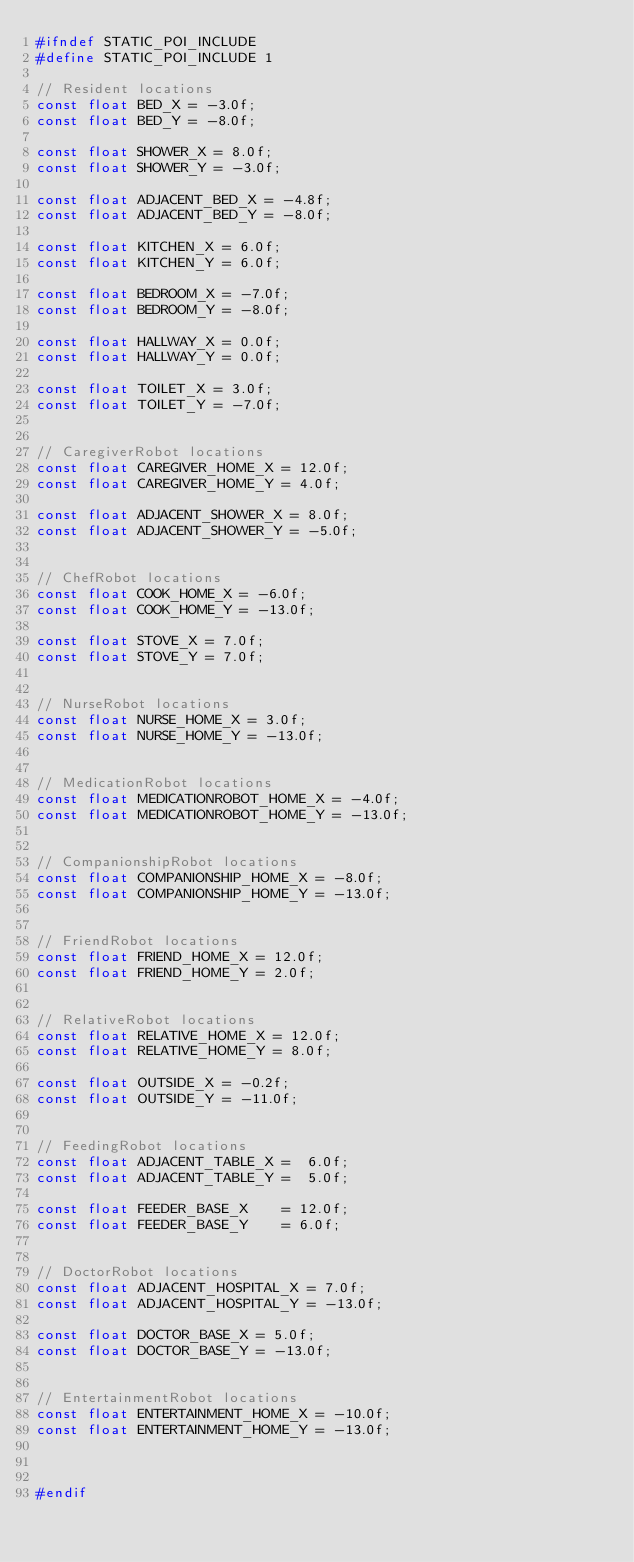Convert code to text. <code><loc_0><loc_0><loc_500><loc_500><_C_>#ifndef STATIC_POI_INCLUDE
#define STATIC_POI_INCLUDE 1

// Resident locations
const float BED_X = -3.0f;
const float BED_Y = -8.0f;

const float SHOWER_X = 8.0f;
const float SHOWER_Y = -3.0f;

const float ADJACENT_BED_X = -4.8f;
const float ADJACENT_BED_Y = -8.0f;

const float KITCHEN_X = 6.0f;
const float KITCHEN_Y = 6.0f;

const float BEDROOM_X = -7.0f;
const float BEDROOM_Y = -8.0f;

const float HALLWAY_X = 0.0f;
const float HALLWAY_Y = 0.0f;

const float TOILET_X = 3.0f;
const float TOILET_Y = -7.0f;


// CaregiverRobot locations
const float CAREGIVER_HOME_X = 12.0f;
const float CAREGIVER_HOME_Y = 4.0f;

const float ADJACENT_SHOWER_X = 8.0f;
const float ADJACENT_SHOWER_Y = -5.0f;


// ChefRobot locations
const float COOK_HOME_X = -6.0f;
const float COOK_HOME_Y = -13.0f;

const float STOVE_X = 7.0f;
const float STOVE_Y = 7.0f;


// NurseRobot locations
const float NURSE_HOME_X = 3.0f;
const float NURSE_HOME_Y = -13.0f;


// MedicationRobot locations
const float MEDICATIONROBOT_HOME_X = -4.0f;
const float MEDICATIONROBOT_HOME_Y = -13.0f;


// CompanionshipRobot locations
const float COMPANIONSHIP_HOME_X = -8.0f;
const float COMPANIONSHIP_HOME_Y = -13.0f;


// FriendRobot locations
const float FRIEND_HOME_X = 12.0f;
const float FRIEND_HOME_Y = 2.0f;


// RelativeRobot locations
const float RELATIVE_HOME_X = 12.0f;
const float RELATIVE_HOME_Y = 8.0f;

const float OUTSIDE_X = -0.2f;
const float OUTSIDE_Y = -11.0f;


// FeedingRobot locations
const float ADJACENT_TABLE_X =  6.0f;
const float ADJACENT_TABLE_Y =  5.0f;

const float FEEDER_BASE_X    = 12.0f;
const float FEEDER_BASE_Y    = 6.0f;


// DoctorRobot locations
const float ADJACENT_HOSPITAL_X = 7.0f;
const float ADJACENT_HOSPITAL_Y = -13.0f;

const float DOCTOR_BASE_X = 5.0f;
const float DOCTOR_BASE_Y = -13.0f;


// EntertainmentRobot locations
const float ENTERTAINMENT_HOME_X = -10.0f;
const float ENTERTAINMENT_HOME_Y = -13.0f;



#endif
</code> 